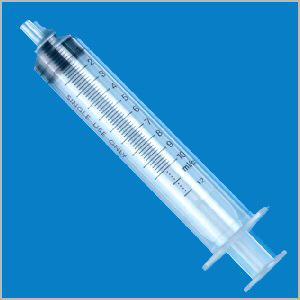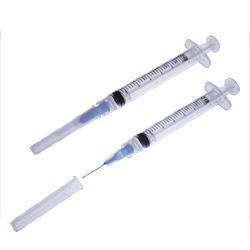The first image is the image on the left, the second image is the image on the right. For the images displayed, is the sentence "There are two orange colored syringes." factually correct? Answer yes or no. No. The first image is the image on the left, the second image is the image on the right. For the images shown, is this caption "Each of the syringes has an orange plunger." true? Answer yes or no. No. 